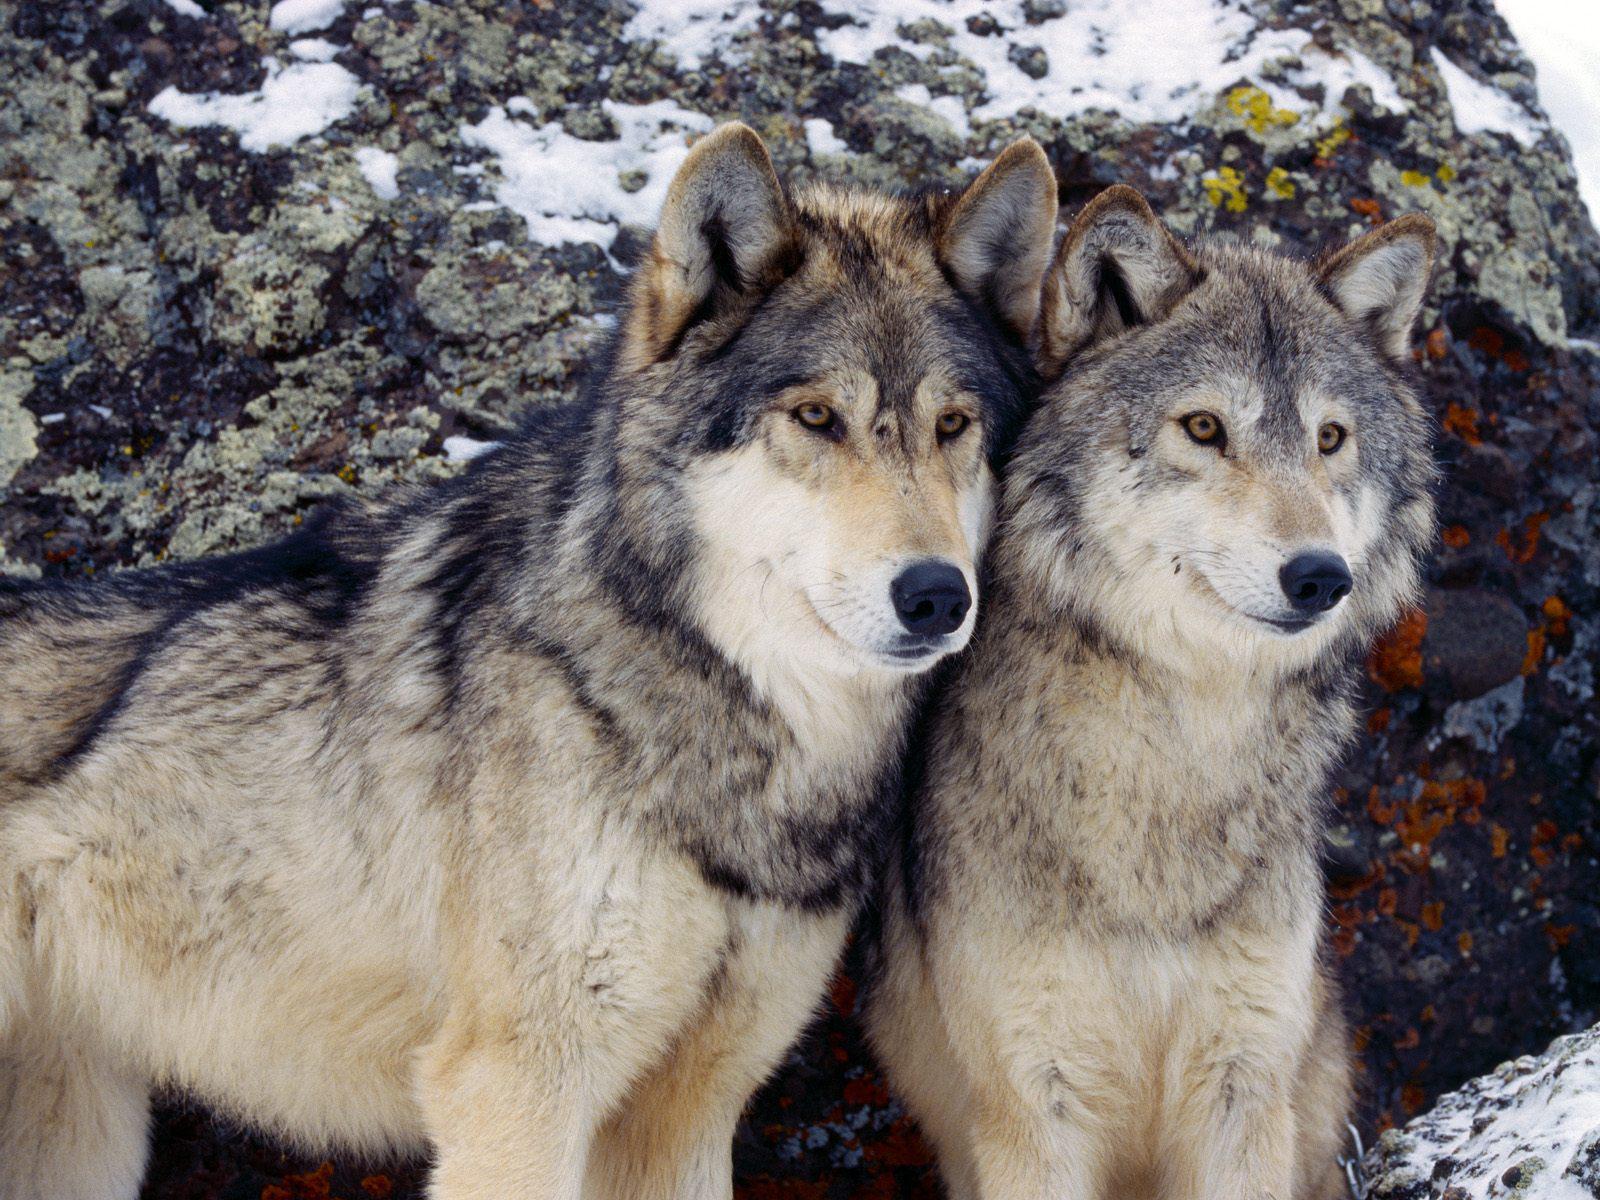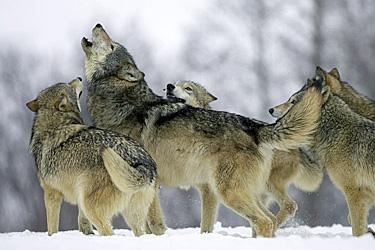The first image is the image on the left, the second image is the image on the right. Examine the images to the left and right. Is the description "The right image contains five wolves." accurate? Answer yes or no. Yes. The first image is the image on the left, the second image is the image on the right. Analyze the images presented: Is the assertion "One image contains only non-howling wolves with non-raised heads, and the other image includes wolves howling with raised heads." valid? Answer yes or no. Yes. 